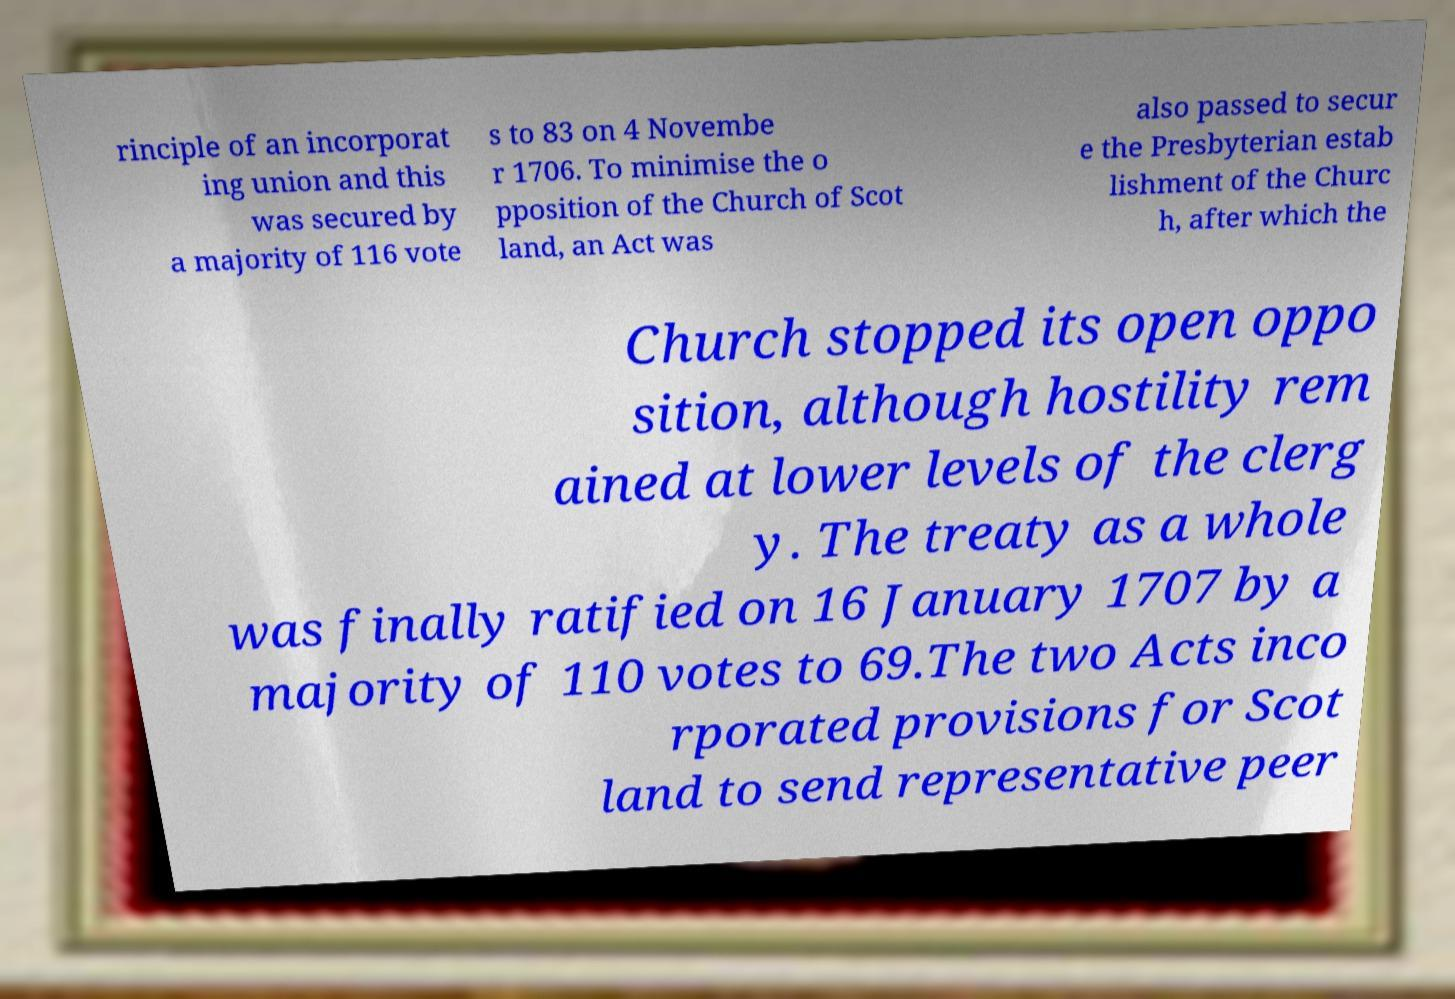Can you read and provide the text displayed in the image?This photo seems to have some interesting text. Can you extract and type it out for me? rinciple of an incorporat ing union and this was secured by a majority of 116 vote s to 83 on 4 Novembe r 1706. To minimise the o pposition of the Church of Scot land, an Act was also passed to secur e the Presbyterian estab lishment of the Churc h, after which the Church stopped its open oppo sition, although hostility rem ained at lower levels of the clerg y. The treaty as a whole was finally ratified on 16 January 1707 by a majority of 110 votes to 69.The two Acts inco rporated provisions for Scot land to send representative peer 